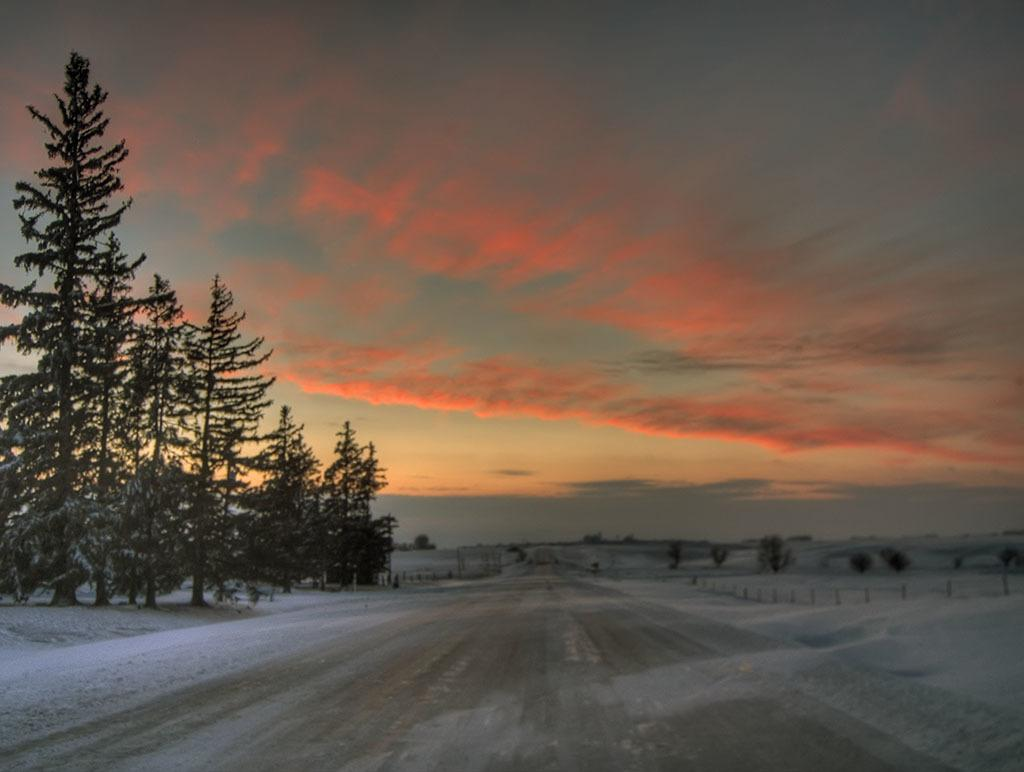What is the main feature of the image? There is a road in the image. What is the condition of the environment surrounding the road? Snow is present on both sides of the road. What type of vegetation can be seen near the road? There are trees to the left of the road. What is the color of the sky in the image? The sky is red at the top of the image. What type of surprise can be seen in the image? There is no surprise present in the image; it features a road, snow, trees, and a red sky. Are there any police officers visible in the image? There is no indication of police officers in the image. 